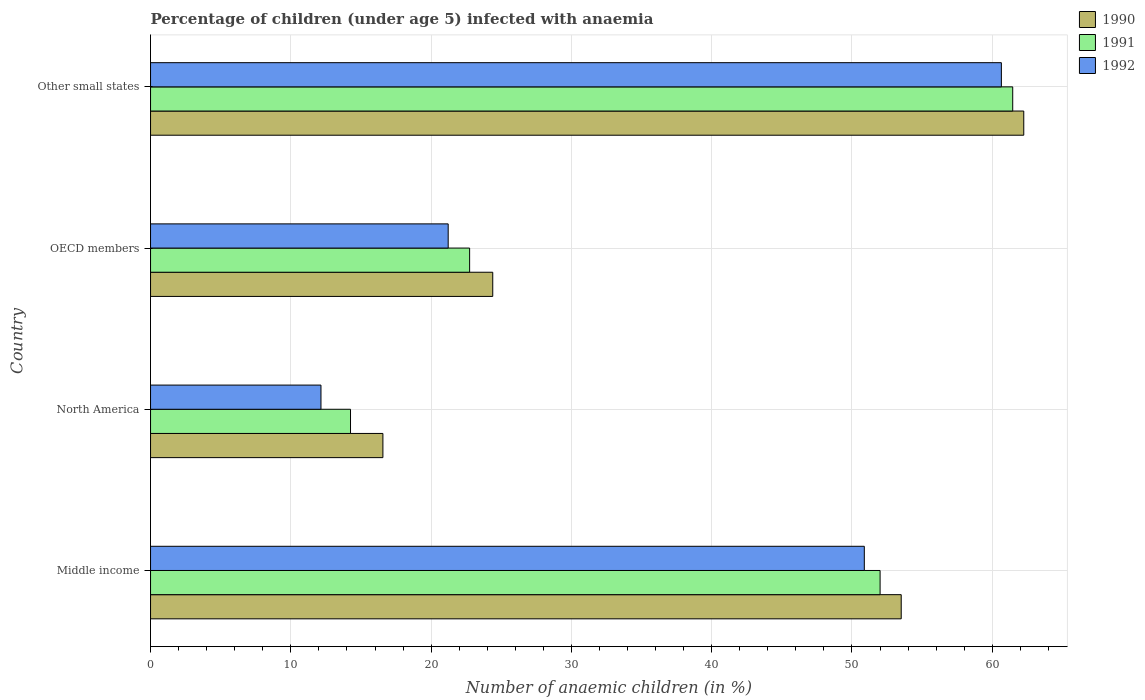How many groups of bars are there?
Give a very brief answer. 4. How many bars are there on the 1st tick from the bottom?
Make the answer very short. 3. What is the label of the 1st group of bars from the top?
Provide a short and direct response. Other small states. In how many cases, is the number of bars for a given country not equal to the number of legend labels?
Keep it short and to the point. 0. What is the percentage of children infected with anaemia in in 1992 in Other small states?
Keep it short and to the point. 60.65. Across all countries, what is the maximum percentage of children infected with anaemia in in 1990?
Make the answer very short. 62.25. Across all countries, what is the minimum percentage of children infected with anaemia in in 1990?
Your response must be concise. 16.56. In which country was the percentage of children infected with anaemia in in 1991 maximum?
Your answer should be compact. Other small states. What is the total percentage of children infected with anaemia in in 1992 in the graph?
Make the answer very short. 144.89. What is the difference between the percentage of children infected with anaemia in in 1990 in Middle income and that in Other small states?
Keep it short and to the point. -8.74. What is the difference between the percentage of children infected with anaemia in in 1992 in Middle income and the percentage of children infected with anaemia in in 1991 in Other small states?
Ensure brevity in your answer.  -10.58. What is the average percentage of children infected with anaemia in in 1991 per country?
Provide a short and direct response. 37.62. What is the difference between the percentage of children infected with anaemia in in 1990 and percentage of children infected with anaemia in in 1991 in Other small states?
Ensure brevity in your answer.  0.79. What is the ratio of the percentage of children infected with anaemia in in 1990 in Middle income to that in North America?
Give a very brief answer. 3.23. Is the percentage of children infected with anaemia in in 1990 in Middle income less than that in Other small states?
Your response must be concise. Yes. What is the difference between the highest and the second highest percentage of children infected with anaemia in in 1990?
Offer a terse response. 8.74. What is the difference between the highest and the lowest percentage of children infected with anaemia in in 1992?
Your answer should be very brief. 48.5. In how many countries, is the percentage of children infected with anaemia in in 1991 greater than the average percentage of children infected with anaemia in in 1991 taken over all countries?
Keep it short and to the point. 2. What does the 1st bar from the bottom in North America represents?
Offer a terse response. 1990. Is it the case that in every country, the sum of the percentage of children infected with anaemia in in 1990 and percentage of children infected with anaemia in in 1991 is greater than the percentage of children infected with anaemia in in 1992?
Provide a succinct answer. Yes. How many bars are there?
Offer a very short reply. 12. Are all the bars in the graph horizontal?
Give a very brief answer. Yes. What is the difference between two consecutive major ticks on the X-axis?
Provide a succinct answer. 10. Are the values on the major ticks of X-axis written in scientific E-notation?
Give a very brief answer. No. Does the graph contain grids?
Provide a succinct answer. Yes. Where does the legend appear in the graph?
Make the answer very short. Top right. How are the legend labels stacked?
Keep it short and to the point. Vertical. What is the title of the graph?
Provide a short and direct response. Percentage of children (under age 5) infected with anaemia. Does "1999" appear as one of the legend labels in the graph?
Give a very brief answer. No. What is the label or title of the X-axis?
Your answer should be compact. Number of anaemic children (in %). What is the Number of anaemic children (in %) of 1990 in Middle income?
Ensure brevity in your answer.  53.51. What is the Number of anaemic children (in %) of 1991 in Middle income?
Your answer should be compact. 52. What is the Number of anaemic children (in %) of 1992 in Middle income?
Your answer should be very brief. 50.88. What is the Number of anaemic children (in %) of 1990 in North America?
Your response must be concise. 16.56. What is the Number of anaemic children (in %) in 1991 in North America?
Offer a terse response. 14.26. What is the Number of anaemic children (in %) of 1992 in North America?
Keep it short and to the point. 12.15. What is the Number of anaemic children (in %) of 1990 in OECD members?
Give a very brief answer. 24.39. What is the Number of anaemic children (in %) in 1991 in OECD members?
Your answer should be compact. 22.75. What is the Number of anaemic children (in %) of 1992 in OECD members?
Keep it short and to the point. 21.22. What is the Number of anaemic children (in %) of 1990 in Other small states?
Offer a terse response. 62.25. What is the Number of anaemic children (in %) of 1991 in Other small states?
Provide a succinct answer. 61.46. What is the Number of anaemic children (in %) in 1992 in Other small states?
Your answer should be compact. 60.65. Across all countries, what is the maximum Number of anaemic children (in %) of 1990?
Offer a very short reply. 62.25. Across all countries, what is the maximum Number of anaemic children (in %) in 1991?
Ensure brevity in your answer.  61.46. Across all countries, what is the maximum Number of anaemic children (in %) of 1992?
Your answer should be compact. 60.65. Across all countries, what is the minimum Number of anaemic children (in %) of 1990?
Your answer should be very brief. 16.56. Across all countries, what is the minimum Number of anaemic children (in %) of 1991?
Your answer should be compact. 14.26. Across all countries, what is the minimum Number of anaemic children (in %) in 1992?
Offer a very short reply. 12.15. What is the total Number of anaemic children (in %) in 1990 in the graph?
Provide a short and direct response. 156.71. What is the total Number of anaemic children (in %) in 1991 in the graph?
Provide a short and direct response. 150.46. What is the total Number of anaemic children (in %) in 1992 in the graph?
Provide a succinct answer. 144.89. What is the difference between the Number of anaemic children (in %) in 1990 in Middle income and that in North America?
Offer a very short reply. 36.95. What is the difference between the Number of anaemic children (in %) in 1991 in Middle income and that in North America?
Provide a succinct answer. 37.75. What is the difference between the Number of anaemic children (in %) of 1992 in Middle income and that in North America?
Your response must be concise. 38.73. What is the difference between the Number of anaemic children (in %) in 1990 in Middle income and that in OECD members?
Keep it short and to the point. 29.12. What is the difference between the Number of anaemic children (in %) in 1991 in Middle income and that in OECD members?
Make the answer very short. 29.26. What is the difference between the Number of anaemic children (in %) of 1992 in Middle income and that in OECD members?
Make the answer very short. 29.66. What is the difference between the Number of anaemic children (in %) of 1990 in Middle income and that in Other small states?
Ensure brevity in your answer.  -8.74. What is the difference between the Number of anaemic children (in %) in 1991 in Middle income and that in Other small states?
Offer a very short reply. -9.45. What is the difference between the Number of anaemic children (in %) in 1992 in Middle income and that in Other small states?
Ensure brevity in your answer.  -9.77. What is the difference between the Number of anaemic children (in %) in 1990 in North America and that in OECD members?
Offer a terse response. -7.83. What is the difference between the Number of anaemic children (in %) in 1991 in North America and that in OECD members?
Provide a short and direct response. -8.49. What is the difference between the Number of anaemic children (in %) in 1992 in North America and that in OECD members?
Your answer should be compact. -9.07. What is the difference between the Number of anaemic children (in %) of 1990 in North America and that in Other small states?
Make the answer very short. -45.68. What is the difference between the Number of anaemic children (in %) of 1991 in North America and that in Other small states?
Your answer should be very brief. -47.2. What is the difference between the Number of anaemic children (in %) of 1992 in North America and that in Other small states?
Ensure brevity in your answer.  -48.5. What is the difference between the Number of anaemic children (in %) in 1990 in OECD members and that in Other small states?
Ensure brevity in your answer.  -37.85. What is the difference between the Number of anaemic children (in %) of 1991 in OECD members and that in Other small states?
Offer a terse response. -38.71. What is the difference between the Number of anaemic children (in %) of 1992 in OECD members and that in Other small states?
Your response must be concise. -39.43. What is the difference between the Number of anaemic children (in %) in 1990 in Middle income and the Number of anaemic children (in %) in 1991 in North America?
Provide a short and direct response. 39.25. What is the difference between the Number of anaemic children (in %) of 1990 in Middle income and the Number of anaemic children (in %) of 1992 in North America?
Offer a very short reply. 41.36. What is the difference between the Number of anaemic children (in %) of 1991 in Middle income and the Number of anaemic children (in %) of 1992 in North America?
Your answer should be compact. 39.86. What is the difference between the Number of anaemic children (in %) of 1990 in Middle income and the Number of anaemic children (in %) of 1991 in OECD members?
Ensure brevity in your answer.  30.76. What is the difference between the Number of anaemic children (in %) in 1990 in Middle income and the Number of anaemic children (in %) in 1992 in OECD members?
Give a very brief answer. 32.29. What is the difference between the Number of anaemic children (in %) of 1991 in Middle income and the Number of anaemic children (in %) of 1992 in OECD members?
Give a very brief answer. 30.79. What is the difference between the Number of anaemic children (in %) of 1990 in Middle income and the Number of anaemic children (in %) of 1991 in Other small states?
Your response must be concise. -7.95. What is the difference between the Number of anaemic children (in %) in 1990 in Middle income and the Number of anaemic children (in %) in 1992 in Other small states?
Make the answer very short. -7.14. What is the difference between the Number of anaemic children (in %) in 1991 in Middle income and the Number of anaemic children (in %) in 1992 in Other small states?
Your answer should be very brief. -8.64. What is the difference between the Number of anaemic children (in %) of 1990 in North America and the Number of anaemic children (in %) of 1991 in OECD members?
Keep it short and to the point. -6.18. What is the difference between the Number of anaemic children (in %) in 1990 in North America and the Number of anaemic children (in %) in 1992 in OECD members?
Ensure brevity in your answer.  -4.65. What is the difference between the Number of anaemic children (in %) of 1991 in North America and the Number of anaemic children (in %) of 1992 in OECD members?
Make the answer very short. -6.96. What is the difference between the Number of anaemic children (in %) of 1990 in North America and the Number of anaemic children (in %) of 1991 in Other small states?
Keep it short and to the point. -44.89. What is the difference between the Number of anaemic children (in %) of 1990 in North America and the Number of anaemic children (in %) of 1992 in Other small states?
Offer a very short reply. -44.09. What is the difference between the Number of anaemic children (in %) in 1991 in North America and the Number of anaemic children (in %) in 1992 in Other small states?
Your response must be concise. -46.39. What is the difference between the Number of anaemic children (in %) of 1990 in OECD members and the Number of anaemic children (in %) of 1991 in Other small states?
Give a very brief answer. -37.06. What is the difference between the Number of anaemic children (in %) of 1990 in OECD members and the Number of anaemic children (in %) of 1992 in Other small states?
Offer a very short reply. -36.26. What is the difference between the Number of anaemic children (in %) in 1991 in OECD members and the Number of anaemic children (in %) in 1992 in Other small states?
Keep it short and to the point. -37.9. What is the average Number of anaemic children (in %) of 1990 per country?
Provide a succinct answer. 39.18. What is the average Number of anaemic children (in %) of 1991 per country?
Make the answer very short. 37.62. What is the average Number of anaemic children (in %) in 1992 per country?
Offer a terse response. 36.22. What is the difference between the Number of anaemic children (in %) in 1990 and Number of anaemic children (in %) in 1991 in Middle income?
Provide a short and direct response. 1.51. What is the difference between the Number of anaemic children (in %) in 1990 and Number of anaemic children (in %) in 1992 in Middle income?
Offer a very short reply. 2.63. What is the difference between the Number of anaemic children (in %) in 1991 and Number of anaemic children (in %) in 1992 in Middle income?
Your answer should be compact. 1.13. What is the difference between the Number of anaemic children (in %) in 1990 and Number of anaemic children (in %) in 1991 in North America?
Provide a short and direct response. 2.31. What is the difference between the Number of anaemic children (in %) of 1990 and Number of anaemic children (in %) of 1992 in North America?
Provide a succinct answer. 4.41. What is the difference between the Number of anaemic children (in %) of 1991 and Number of anaemic children (in %) of 1992 in North America?
Keep it short and to the point. 2.11. What is the difference between the Number of anaemic children (in %) in 1990 and Number of anaemic children (in %) in 1991 in OECD members?
Provide a succinct answer. 1.65. What is the difference between the Number of anaemic children (in %) in 1990 and Number of anaemic children (in %) in 1992 in OECD members?
Ensure brevity in your answer.  3.18. What is the difference between the Number of anaemic children (in %) in 1991 and Number of anaemic children (in %) in 1992 in OECD members?
Make the answer very short. 1.53. What is the difference between the Number of anaemic children (in %) in 1990 and Number of anaemic children (in %) in 1991 in Other small states?
Ensure brevity in your answer.  0.79. What is the difference between the Number of anaemic children (in %) in 1990 and Number of anaemic children (in %) in 1992 in Other small states?
Offer a terse response. 1.6. What is the difference between the Number of anaemic children (in %) of 1991 and Number of anaemic children (in %) of 1992 in Other small states?
Your response must be concise. 0.81. What is the ratio of the Number of anaemic children (in %) in 1990 in Middle income to that in North America?
Provide a succinct answer. 3.23. What is the ratio of the Number of anaemic children (in %) in 1991 in Middle income to that in North America?
Your response must be concise. 3.65. What is the ratio of the Number of anaemic children (in %) in 1992 in Middle income to that in North America?
Keep it short and to the point. 4.19. What is the ratio of the Number of anaemic children (in %) of 1990 in Middle income to that in OECD members?
Give a very brief answer. 2.19. What is the ratio of the Number of anaemic children (in %) of 1991 in Middle income to that in OECD members?
Provide a short and direct response. 2.29. What is the ratio of the Number of anaemic children (in %) of 1992 in Middle income to that in OECD members?
Your answer should be very brief. 2.4. What is the ratio of the Number of anaemic children (in %) in 1990 in Middle income to that in Other small states?
Make the answer very short. 0.86. What is the ratio of the Number of anaemic children (in %) of 1991 in Middle income to that in Other small states?
Your answer should be very brief. 0.85. What is the ratio of the Number of anaemic children (in %) of 1992 in Middle income to that in Other small states?
Make the answer very short. 0.84. What is the ratio of the Number of anaemic children (in %) in 1990 in North America to that in OECD members?
Provide a succinct answer. 0.68. What is the ratio of the Number of anaemic children (in %) of 1991 in North America to that in OECD members?
Offer a terse response. 0.63. What is the ratio of the Number of anaemic children (in %) of 1992 in North America to that in OECD members?
Provide a succinct answer. 0.57. What is the ratio of the Number of anaemic children (in %) of 1990 in North America to that in Other small states?
Ensure brevity in your answer.  0.27. What is the ratio of the Number of anaemic children (in %) of 1991 in North America to that in Other small states?
Ensure brevity in your answer.  0.23. What is the ratio of the Number of anaemic children (in %) in 1992 in North America to that in Other small states?
Your answer should be very brief. 0.2. What is the ratio of the Number of anaemic children (in %) in 1990 in OECD members to that in Other small states?
Keep it short and to the point. 0.39. What is the ratio of the Number of anaemic children (in %) in 1991 in OECD members to that in Other small states?
Keep it short and to the point. 0.37. What is the ratio of the Number of anaemic children (in %) of 1992 in OECD members to that in Other small states?
Keep it short and to the point. 0.35. What is the difference between the highest and the second highest Number of anaemic children (in %) in 1990?
Give a very brief answer. 8.74. What is the difference between the highest and the second highest Number of anaemic children (in %) of 1991?
Your answer should be compact. 9.45. What is the difference between the highest and the second highest Number of anaemic children (in %) in 1992?
Give a very brief answer. 9.77. What is the difference between the highest and the lowest Number of anaemic children (in %) of 1990?
Provide a succinct answer. 45.68. What is the difference between the highest and the lowest Number of anaemic children (in %) of 1991?
Provide a succinct answer. 47.2. What is the difference between the highest and the lowest Number of anaemic children (in %) of 1992?
Your answer should be compact. 48.5. 